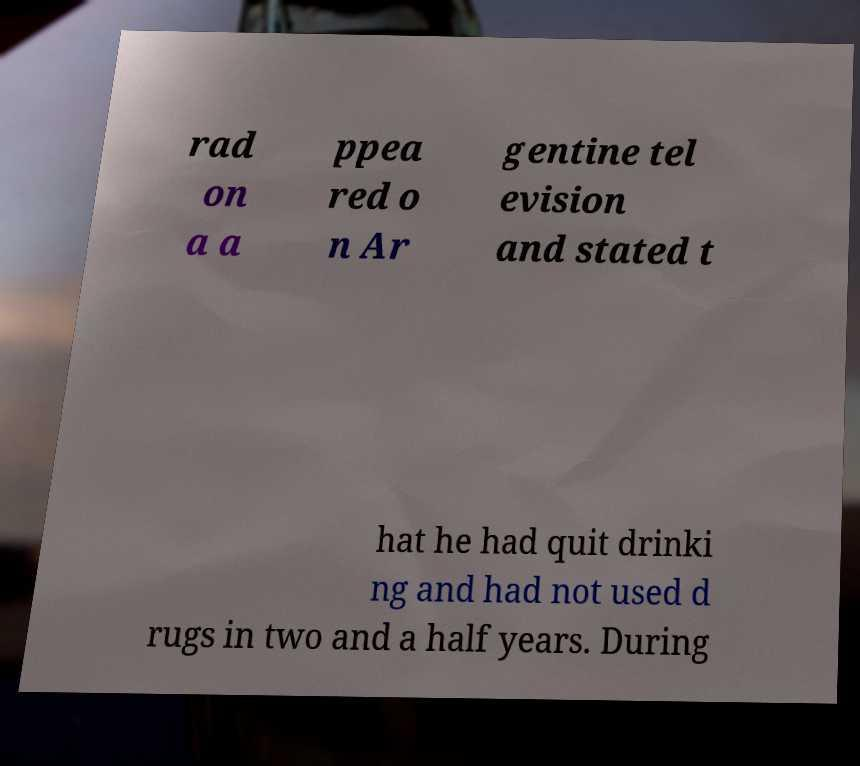Can you read and provide the text displayed in the image?This photo seems to have some interesting text. Can you extract and type it out for me? rad on a a ppea red o n Ar gentine tel evision and stated t hat he had quit drinki ng and had not used d rugs in two and a half years. During 